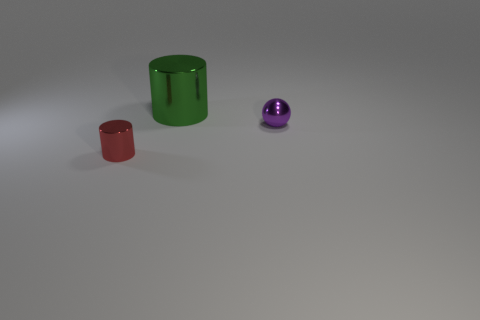Is the big green object made of the same material as the small sphere?
Give a very brief answer. Yes. How many objects are metal things that are in front of the big green thing or metallic cylinders?
Offer a very short reply. 3. How many other objects are the same size as the purple metal ball?
Offer a very short reply. 1. Are there the same number of green shiny things on the left side of the tiny cylinder and things on the left side of the metal sphere?
Your response must be concise. No. What is the color of the small metallic thing that is the same shape as the big object?
Make the answer very short. Red. Are there any other things that are the same shape as the large object?
Keep it short and to the point. Yes. There is a shiny thing behind the purple shiny ball; is it the same color as the small cylinder?
Give a very brief answer. No. There is another thing that is the same shape as the tiny red shiny object; what is its size?
Make the answer very short. Large. What number of large green cylinders are made of the same material as the small cylinder?
Provide a short and direct response. 1. There is a tiny object that is on the left side of the cylinder that is behind the purple ball; is there a red object behind it?
Offer a terse response. No. 